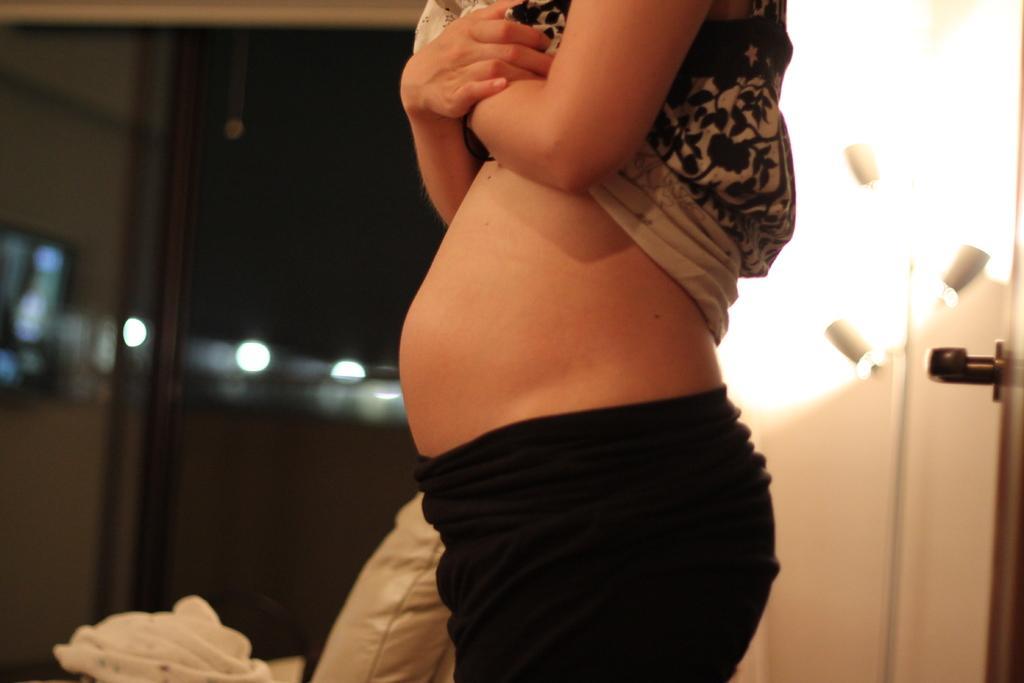In one or two sentences, can you explain what this image depicts? In this image we can see a woman. She is wearing black color pant and white color top. Behind her white color door and pillow is there. 